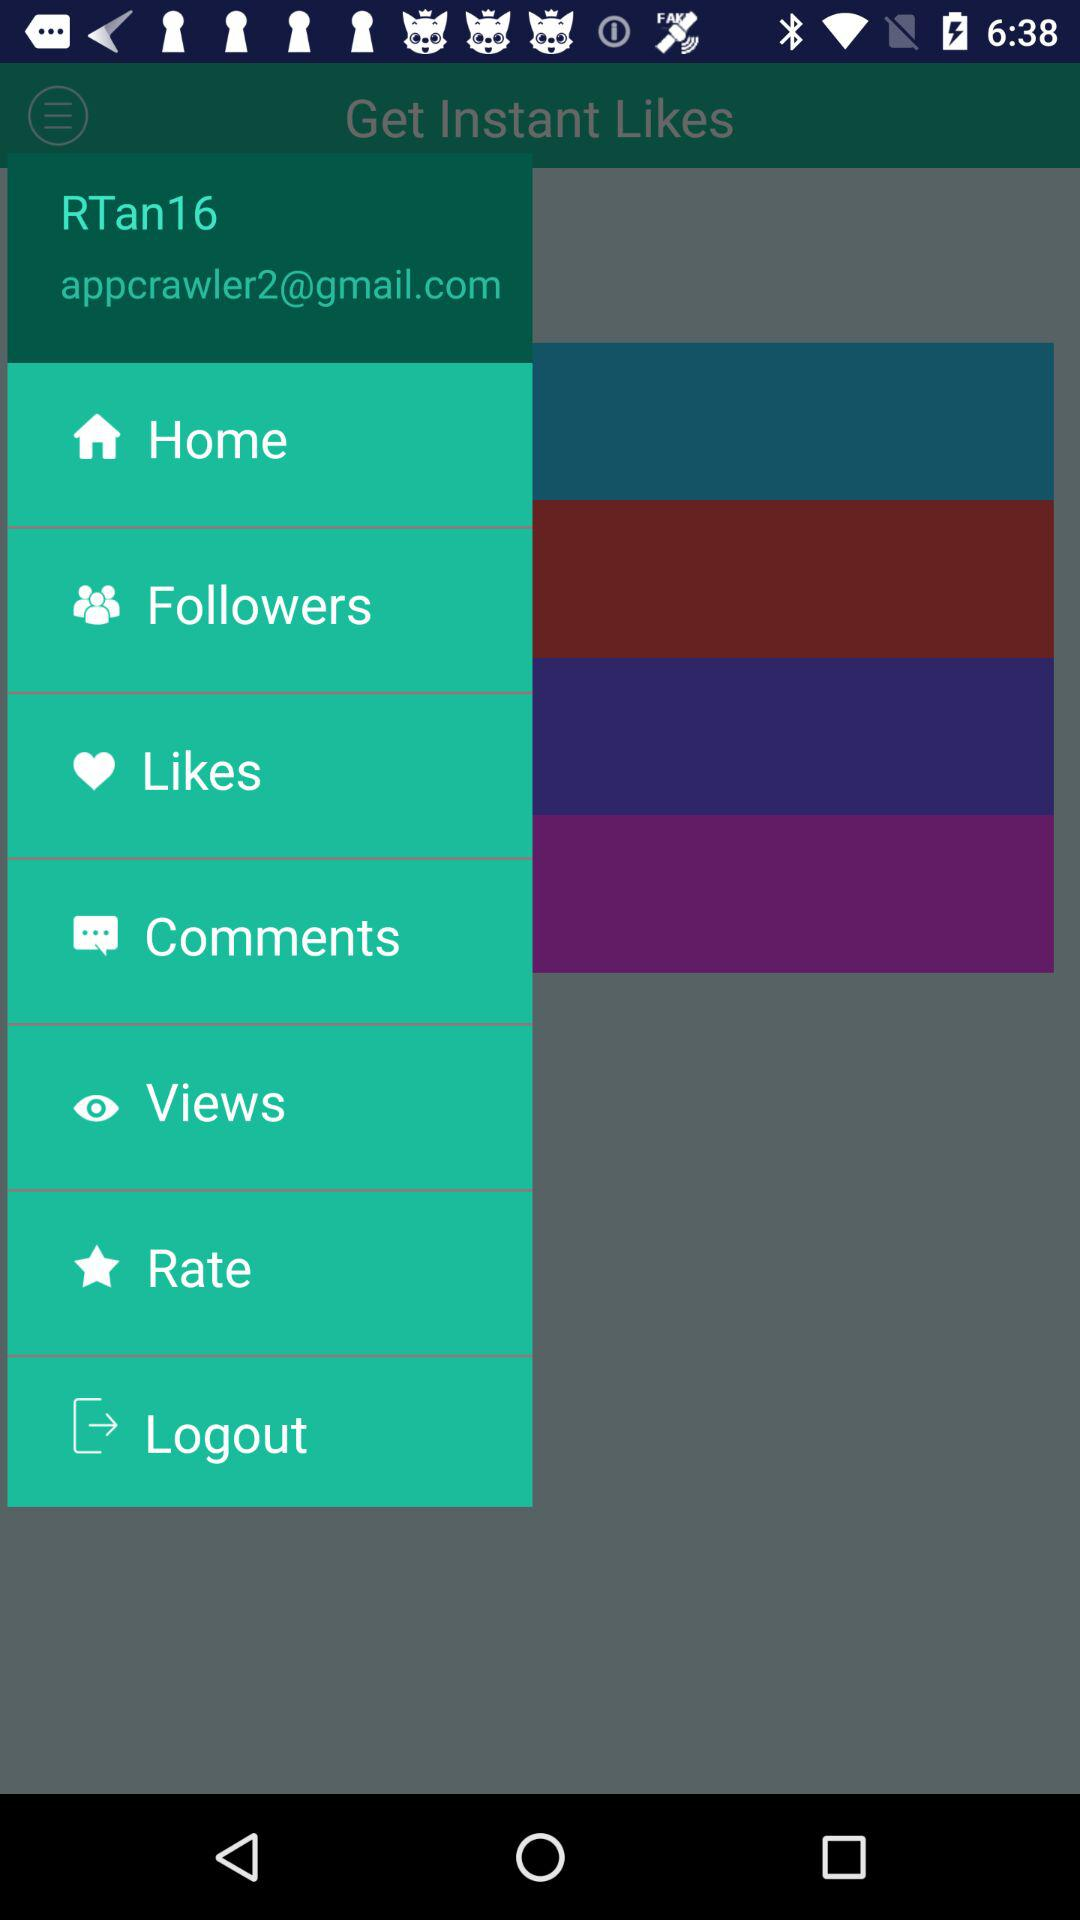How many "Instant Likes" does "RTan16" have?
When the provided information is insufficient, respond with <no answer>. <no answer> 